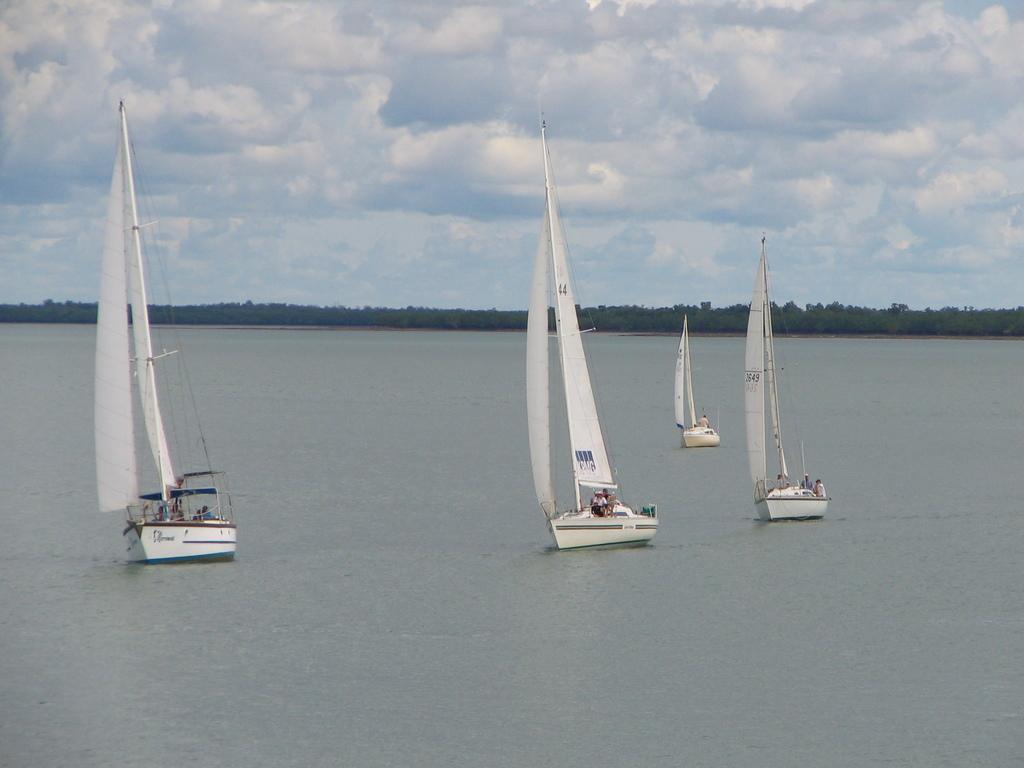Can you describe this image briefly? This picture is clicked outside the city. In the center we can see the sailboats in the water body and we can see there are some persons in the sail boats. In the background there is a sky and the trees. 